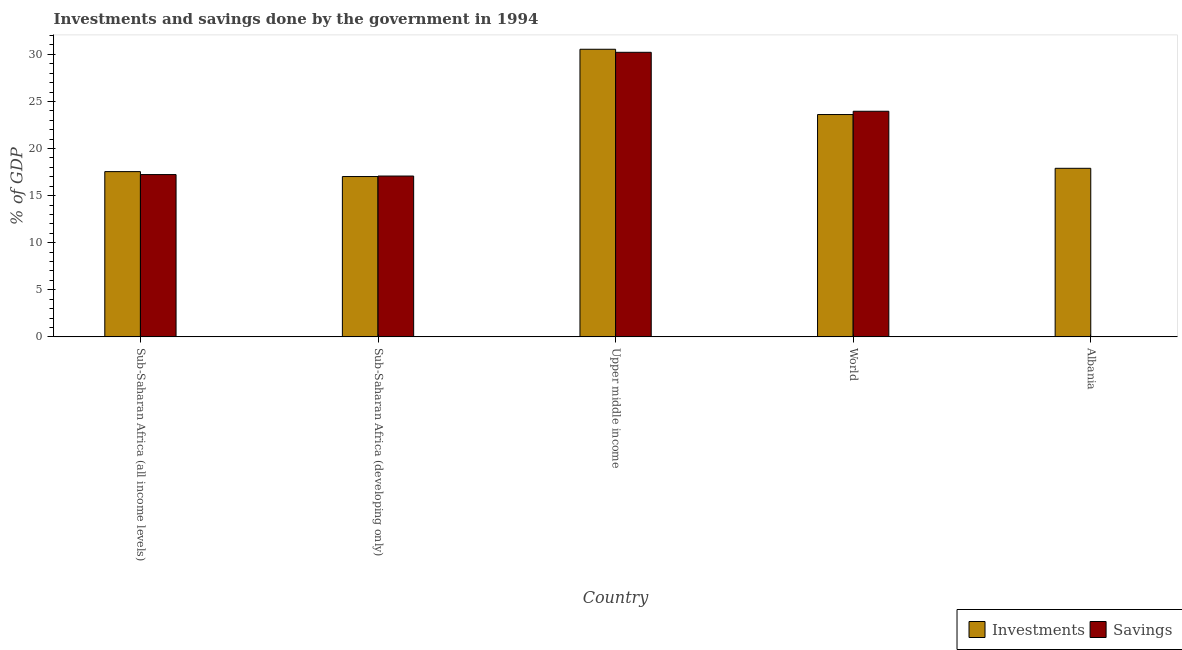Are the number of bars on each tick of the X-axis equal?
Ensure brevity in your answer.  No. What is the investments of government in Sub-Saharan Africa (developing only)?
Offer a very short reply. 17.03. Across all countries, what is the maximum savings of government?
Offer a very short reply. 30.22. Across all countries, what is the minimum investments of government?
Provide a short and direct response. 17.03. In which country was the investments of government maximum?
Make the answer very short. Upper middle income. What is the total savings of government in the graph?
Your answer should be very brief. 88.49. What is the difference between the investments of government in Sub-Saharan Africa (all income levels) and that in Sub-Saharan Africa (developing only)?
Provide a short and direct response. 0.52. What is the difference between the savings of government in Sub-Saharan Africa (all income levels) and the investments of government in Sub-Saharan Africa (developing only)?
Your answer should be compact. 0.21. What is the average investments of government per country?
Provide a short and direct response. 21.33. What is the difference between the investments of government and savings of government in Upper middle income?
Provide a succinct answer. 0.32. What is the ratio of the investments of government in Albania to that in World?
Your answer should be compact. 0.76. What is the difference between the highest and the second highest investments of government?
Your response must be concise. 6.93. What is the difference between the highest and the lowest savings of government?
Provide a short and direct response. 30.22. In how many countries, is the investments of government greater than the average investments of government taken over all countries?
Keep it short and to the point. 2. Are all the bars in the graph horizontal?
Offer a very short reply. No. What is the difference between two consecutive major ticks on the Y-axis?
Your response must be concise. 5. Does the graph contain any zero values?
Your response must be concise. Yes. Does the graph contain grids?
Offer a very short reply. No. What is the title of the graph?
Give a very brief answer. Investments and savings done by the government in 1994. What is the label or title of the Y-axis?
Make the answer very short. % of GDP. What is the % of GDP in Investments in Sub-Saharan Africa (all income levels)?
Give a very brief answer. 17.55. What is the % of GDP of Savings in Sub-Saharan Africa (all income levels)?
Your response must be concise. 17.24. What is the % of GDP of Investments in Sub-Saharan Africa (developing only)?
Keep it short and to the point. 17.03. What is the % of GDP in Savings in Sub-Saharan Africa (developing only)?
Offer a very short reply. 17.08. What is the % of GDP of Investments in Upper middle income?
Ensure brevity in your answer.  30.54. What is the % of GDP of Savings in Upper middle income?
Offer a terse response. 30.22. What is the % of GDP in Investments in World?
Provide a short and direct response. 23.61. What is the % of GDP of Savings in World?
Give a very brief answer. 23.96. What is the % of GDP in Investments in Albania?
Make the answer very short. 17.9. Across all countries, what is the maximum % of GDP in Investments?
Offer a terse response. 30.54. Across all countries, what is the maximum % of GDP of Savings?
Give a very brief answer. 30.22. Across all countries, what is the minimum % of GDP in Investments?
Offer a terse response. 17.03. Across all countries, what is the minimum % of GDP of Savings?
Ensure brevity in your answer.  0. What is the total % of GDP of Investments in the graph?
Make the answer very short. 106.63. What is the total % of GDP in Savings in the graph?
Ensure brevity in your answer.  88.49. What is the difference between the % of GDP of Investments in Sub-Saharan Africa (all income levels) and that in Sub-Saharan Africa (developing only)?
Keep it short and to the point. 0.52. What is the difference between the % of GDP of Savings in Sub-Saharan Africa (all income levels) and that in Sub-Saharan Africa (developing only)?
Provide a succinct answer. 0.16. What is the difference between the % of GDP in Investments in Sub-Saharan Africa (all income levels) and that in Upper middle income?
Your response must be concise. -12.99. What is the difference between the % of GDP of Savings in Sub-Saharan Africa (all income levels) and that in Upper middle income?
Your answer should be very brief. -12.98. What is the difference between the % of GDP of Investments in Sub-Saharan Africa (all income levels) and that in World?
Make the answer very short. -6.06. What is the difference between the % of GDP in Savings in Sub-Saharan Africa (all income levels) and that in World?
Offer a terse response. -6.72. What is the difference between the % of GDP in Investments in Sub-Saharan Africa (all income levels) and that in Albania?
Give a very brief answer. -0.35. What is the difference between the % of GDP in Investments in Sub-Saharan Africa (developing only) and that in Upper middle income?
Your answer should be compact. -13.52. What is the difference between the % of GDP of Savings in Sub-Saharan Africa (developing only) and that in Upper middle income?
Keep it short and to the point. -13.14. What is the difference between the % of GDP in Investments in Sub-Saharan Africa (developing only) and that in World?
Your answer should be compact. -6.58. What is the difference between the % of GDP of Savings in Sub-Saharan Africa (developing only) and that in World?
Your response must be concise. -6.88. What is the difference between the % of GDP of Investments in Sub-Saharan Africa (developing only) and that in Albania?
Offer a terse response. -0.87. What is the difference between the % of GDP of Investments in Upper middle income and that in World?
Make the answer very short. 6.93. What is the difference between the % of GDP in Savings in Upper middle income and that in World?
Keep it short and to the point. 6.26. What is the difference between the % of GDP of Investments in Upper middle income and that in Albania?
Your answer should be compact. 12.64. What is the difference between the % of GDP of Investments in World and that in Albania?
Provide a succinct answer. 5.71. What is the difference between the % of GDP of Investments in Sub-Saharan Africa (all income levels) and the % of GDP of Savings in Sub-Saharan Africa (developing only)?
Your response must be concise. 0.47. What is the difference between the % of GDP of Investments in Sub-Saharan Africa (all income levels) and the % of GDP of Savings in Upper middle income?
Provide a short and direct response. -12.67. What is the difference between the % of GDP in Investments in Sub-Saharan Africa (all income levels) and the % of GDP in Savings in World?
Offer a very short reply. -6.41. What is the difference between the % of GDP of Investments in Sub-Saharan Africa (developing only) and the % of GDP of Savings in Upper middle income?
Offer a very short reply. -13.19. What is the difference between the % of GDP in Investments in Sub-Saharan Africa (developing only) and the % of GDP in Savings in World?
Your response must be concise. -6.93. What is the difference between the % of GDP in Investments in Upper middle income and the % of GDP in Savings in World?
Provide a short and direct response. 6.58. What is the average % of GDP of Investments per country?
Offer a very short reply. 21.33. What is the average % of GDP in Savings per country?
Make the answer very short. 17.7. What is the difference between the % of GDP in Investments and % of GDP in Savings in Sub-Saharan Africa (all income levels)?
Provide a short and direct response. 0.31. What is the difference between the % of GDP in Investments and % of GDP in Savings in Sub-Saharan Africa (developing only)?
Ensure brevity in your answer.  -0.05. What is the difference between the % of GDP in Investments and % of GDP in Savings in Upper middle income?
Make the answer very short. 0.32. What is the difference between the % of GDP of Investments and % of GDP of Savings in World?
Offer a terse response. -0.35. What is the ratio of the % of GDP in Investments in Sub-Saharan Africa (all income levels) to that in Sub-Saharan Africa (developing only)?
Provide a short and direct response. 1.03. What is the ratio of the % of GDP of Savings in Sub-Saharan Africa (all income levels) to that in Sub-Saharan Africa (developing only)?
Make the answer very short. 1.01. What is the ratio of the % of GDP in Investments in Sub-Saharan Africa (all income levels) to that in Upper middle income?
Offer a very short reply. 0.57. What is the ratio of the % of GDP of Savings in Sub-Saharan Africa (all income levels) to that in Upper middle income?
Give a very brief answer. 0.57. What is the ratio of the % of GDP of Investments in Sub-Saharan Africa (all income levels) to that in World?
Give a very brief answer. 0.74. What is the ratio of the % of GDP of Savings in Sub-Saharan Africa (all income levels) to that in World?
Provide a short and direct response. 0.72. What is the ratio of the % of GDP in Investments in Sub-Saharan Africa (all income levels) to that in Albania?
Provide a succinct answer. 0.98. What is the ratio of the % of GDP of Investments in Sub-Saharan Africa (developing only) to that in Upper middle income?
Make the answer very short. 0.56. What is the ratio of the % of GDP of Savings in Sub-Saharan Africa (developing only) to that in Upper middle income?
Provide a succinct answer. 0.57. What is the ratio of the % of GDP in Investments in Sub-Saharan Africa (developing only) to that in World?
Keep it short and to the point. 0.72. What is the ratio of the % of GDP of Savings in Sub-Saharan Africa (developing only) to that in World?
Provide a succinct answer. 0.71. What is the ratio of the % of GDP in Investments in Sub-Saharan Africa (developing only) to that in Albania?
Provide a short and direct response. 0.95. What is the ratio of the % of GDP of Investments in Upper middle income to that in World?
Keep it short and to the point. 1.29. What is the ratio of the % of GDP in Savings in Upper middle income to that in World?
Make the answer very short. 1.26. What is the ratio of the % of GDP of Investments in Upper middle income to that in Albania?
Make the answer very short. 1.71. What is the ratio of the % of GDP of Investments in World to that in Albania?
Make the answer very short. 1.32. What is the difference between the highest and the second highest % of GDP of Investments?
Make the answer very short. 6.93. What is the difference between the highest and the second highest % of GDP in Savings?
Give a very brief answer. 6.26. What is the difference between the highest and the lowest % of GDP in Investments?
Ensure brevity in your answer.  13.52. What is the difference between the highest and the lowest % of GDP of Savings?
Your answer should be compact. 30.22. 